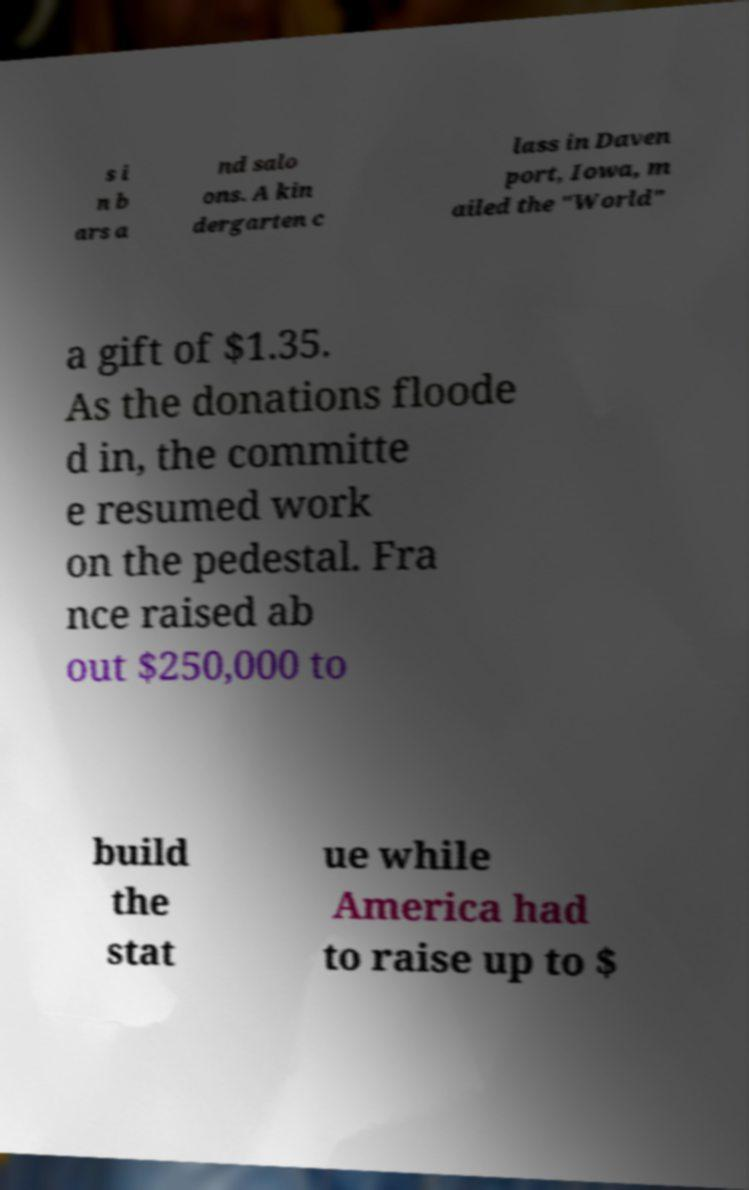Could you extract and type out the text from this image? s i n b ars a nd salo ons. A kin dergarten c lass in Daven port, Iowa, m ailed the "World" a gift of $1.35. As the donations floode d in, the committe e resumed work on the pedestal. Fra nce raised ab out $250,000 to build the stat ue while America had to raise up to $ 